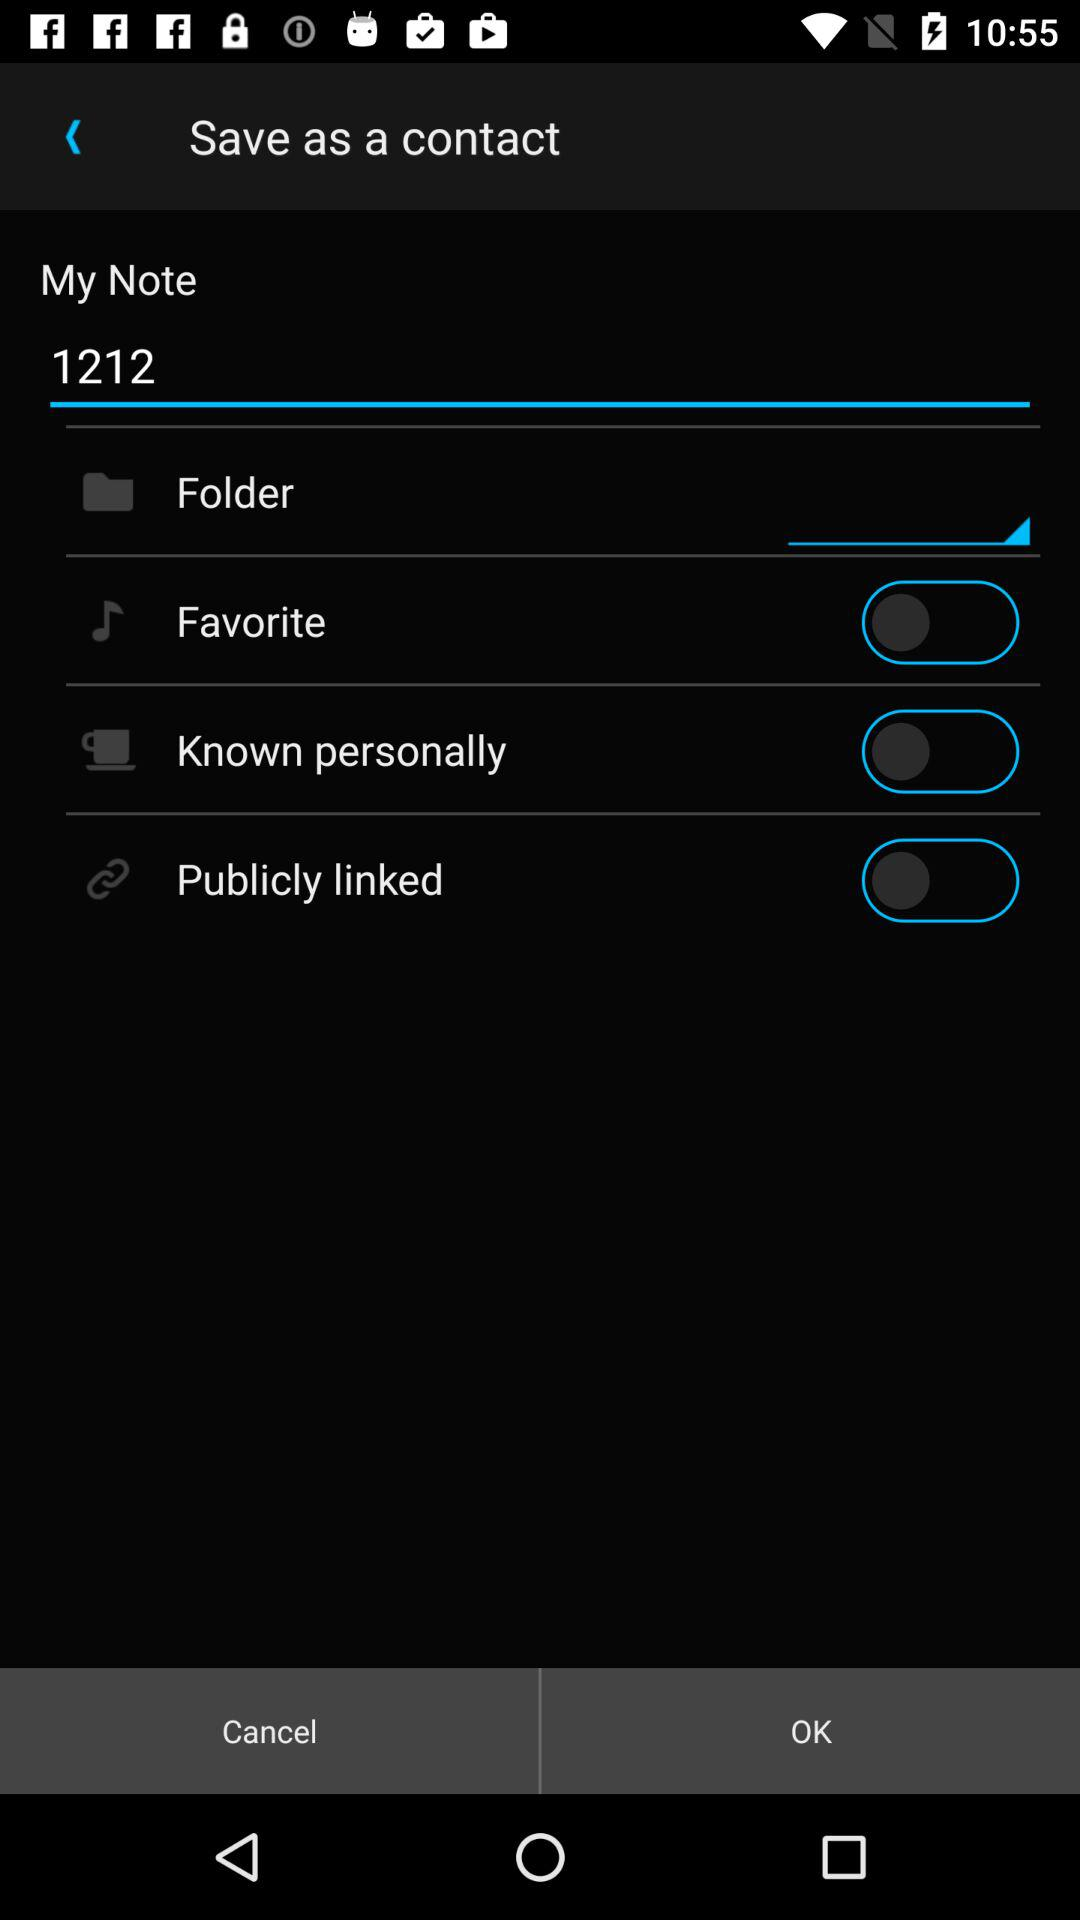What is entered in "My Note"? In "My Note", "1212" is entered. 